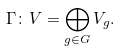Convert formula to latex. <formula><loc_0><loc_0><loc_500><loc_500>\Gamma \colon V = \bigoplus _ { g \in G } V _ { g } .</formula> 